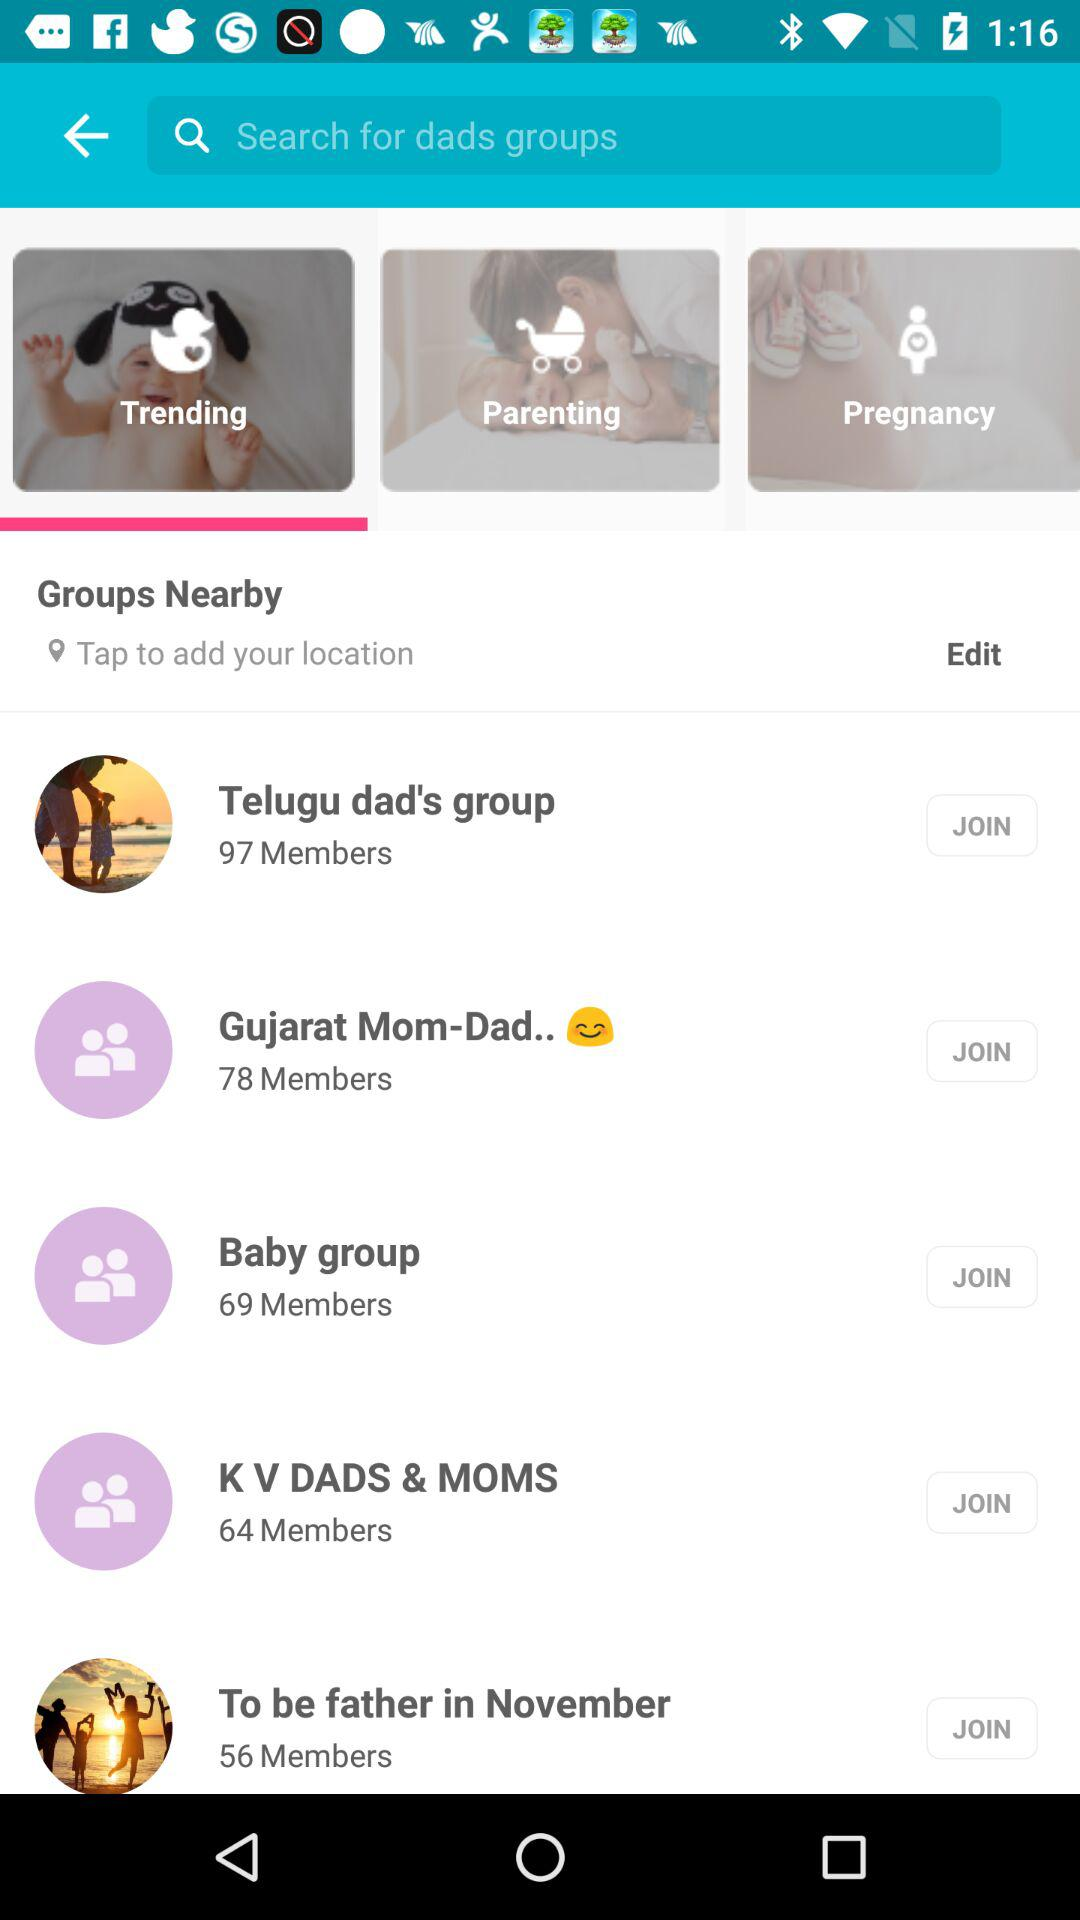How many members are there in a "Baby group"? There are 69 members. 